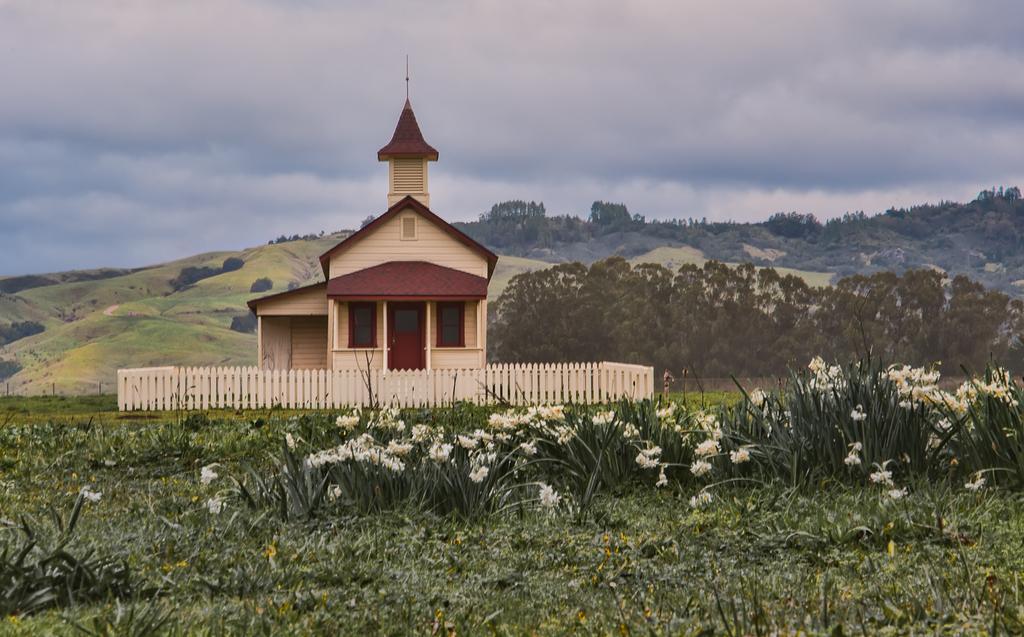Could you give a brief overview of what you see in this image? In this image I can see few flowers in white color, a building in brown and cream color. Background I can see trees in green color and the sky is in blue and white color. 